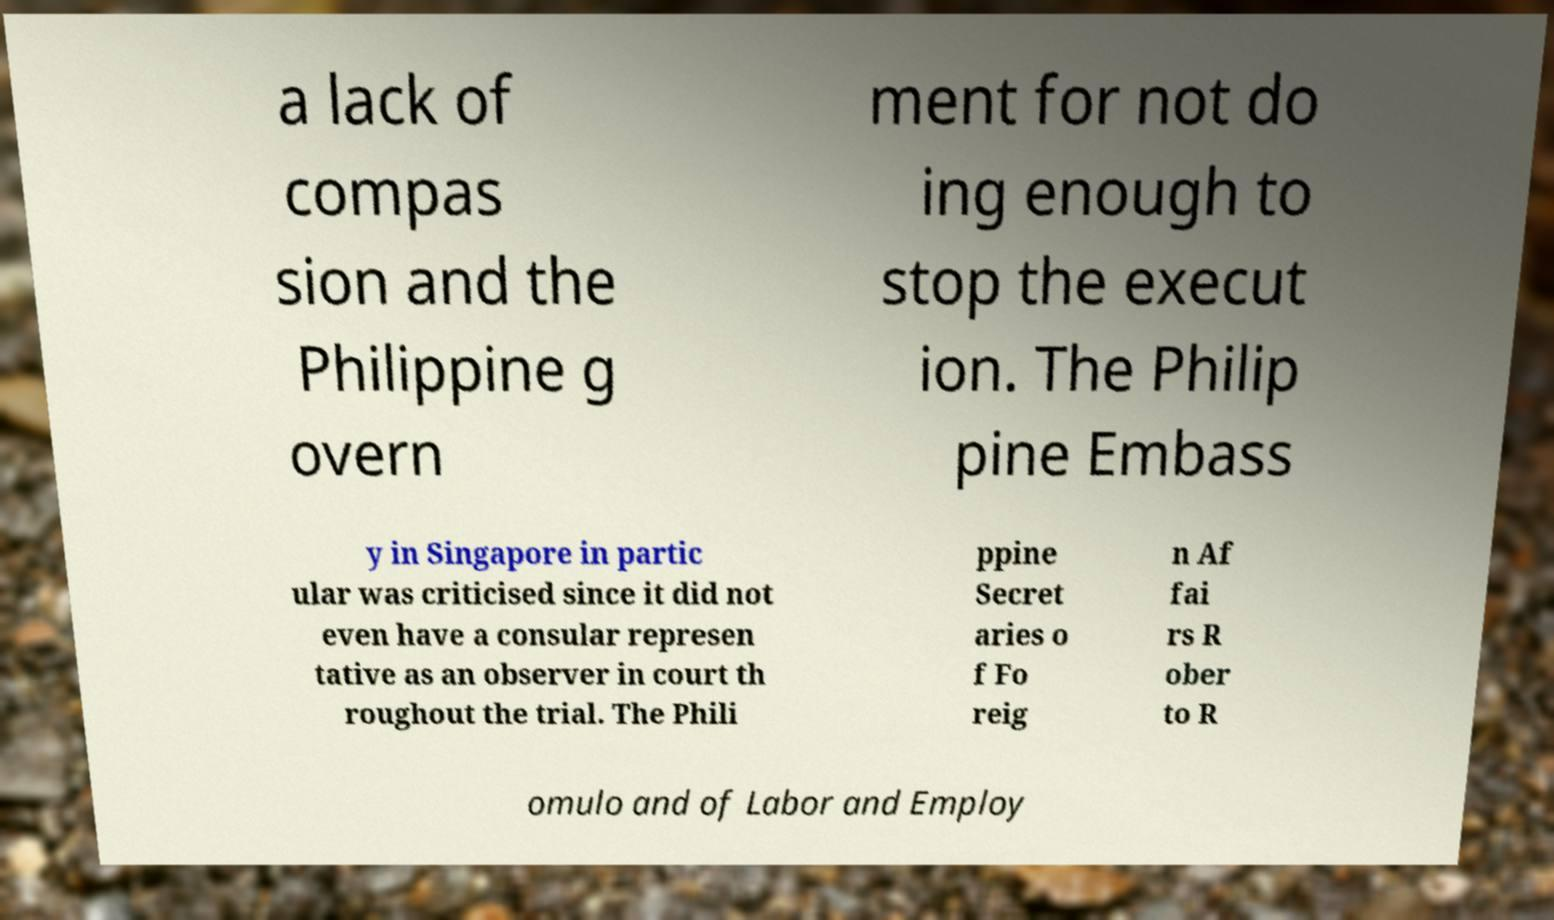Can you read and provide the text displayed in the image?This photo seems to have some interesting text. Can you extract and type it out for me? a lack of compas sion and the Philippine g overn ment for not do ing enough to stop the execut ion. The Philip pine Embass y in Singapore in partic ular was criticised since it did not even have a consular represen tative as an observer in court th roughout the trial. The Phili ppine Secret aries o f Fo reig n Af fai rs R ober to R omulo and of Labor and Employ 